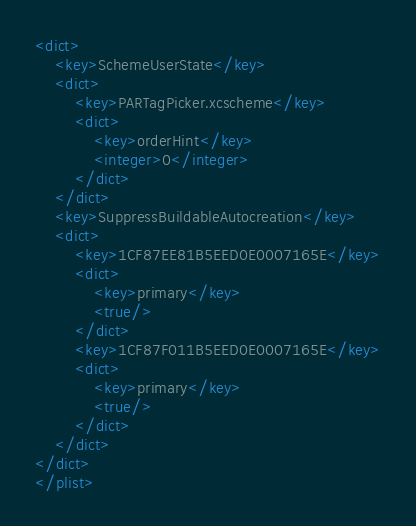Convert code to text. <code><loc_0><loc_0><loc_500><loc_500><_XML_><dict>
	<key>SchemeUserState</key>
	<dict>
		<key>PARTagPicker.xcscheme</key>
		<dict>
			<key>orderHint</key>
			<integer>0</integer>
		</dict>
	</dict>
	<key>SuppressBuildableAutocreation</key>
	<dict>
		<key>1CF87EE81B5EED0E0007165E</key>
		<dict>
			<key>primary</key>
			<true/>
		</dict>
		<key>1CF87F011B5EED0E0007165E</key>
		<dict>
			<key>primary</key>
			<true/>
		</dict>
	</dict>
</dict>
</plist>
</code> 